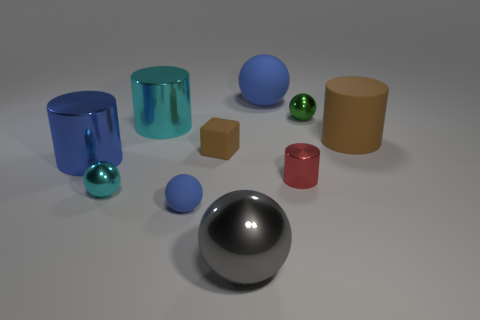Subtract all rubber cylinders. How many cylinders are left? 3 Subtract all purple cubes. How many blue spheres are left? 2 Subtract 2 cylinders. How many cylinders are left? 2 Subtract all gray balls. How many balls are left? 4 Subtract all yellow balls. Subtract all red blocks. How many balls are left? 5 Subtract 0 brown spheres. How many objects are left? 10 Subtract all cylinders. How many objects are left? 6 Subtract all cyan shiny spheres. Subtract all tiny blue matte objects. How many objects are left? 8 Add 2 large gray shiny objects. How many large gray shiny objects are left? 3 Add 5 small green spheres. How many small green spheres exist? 6 